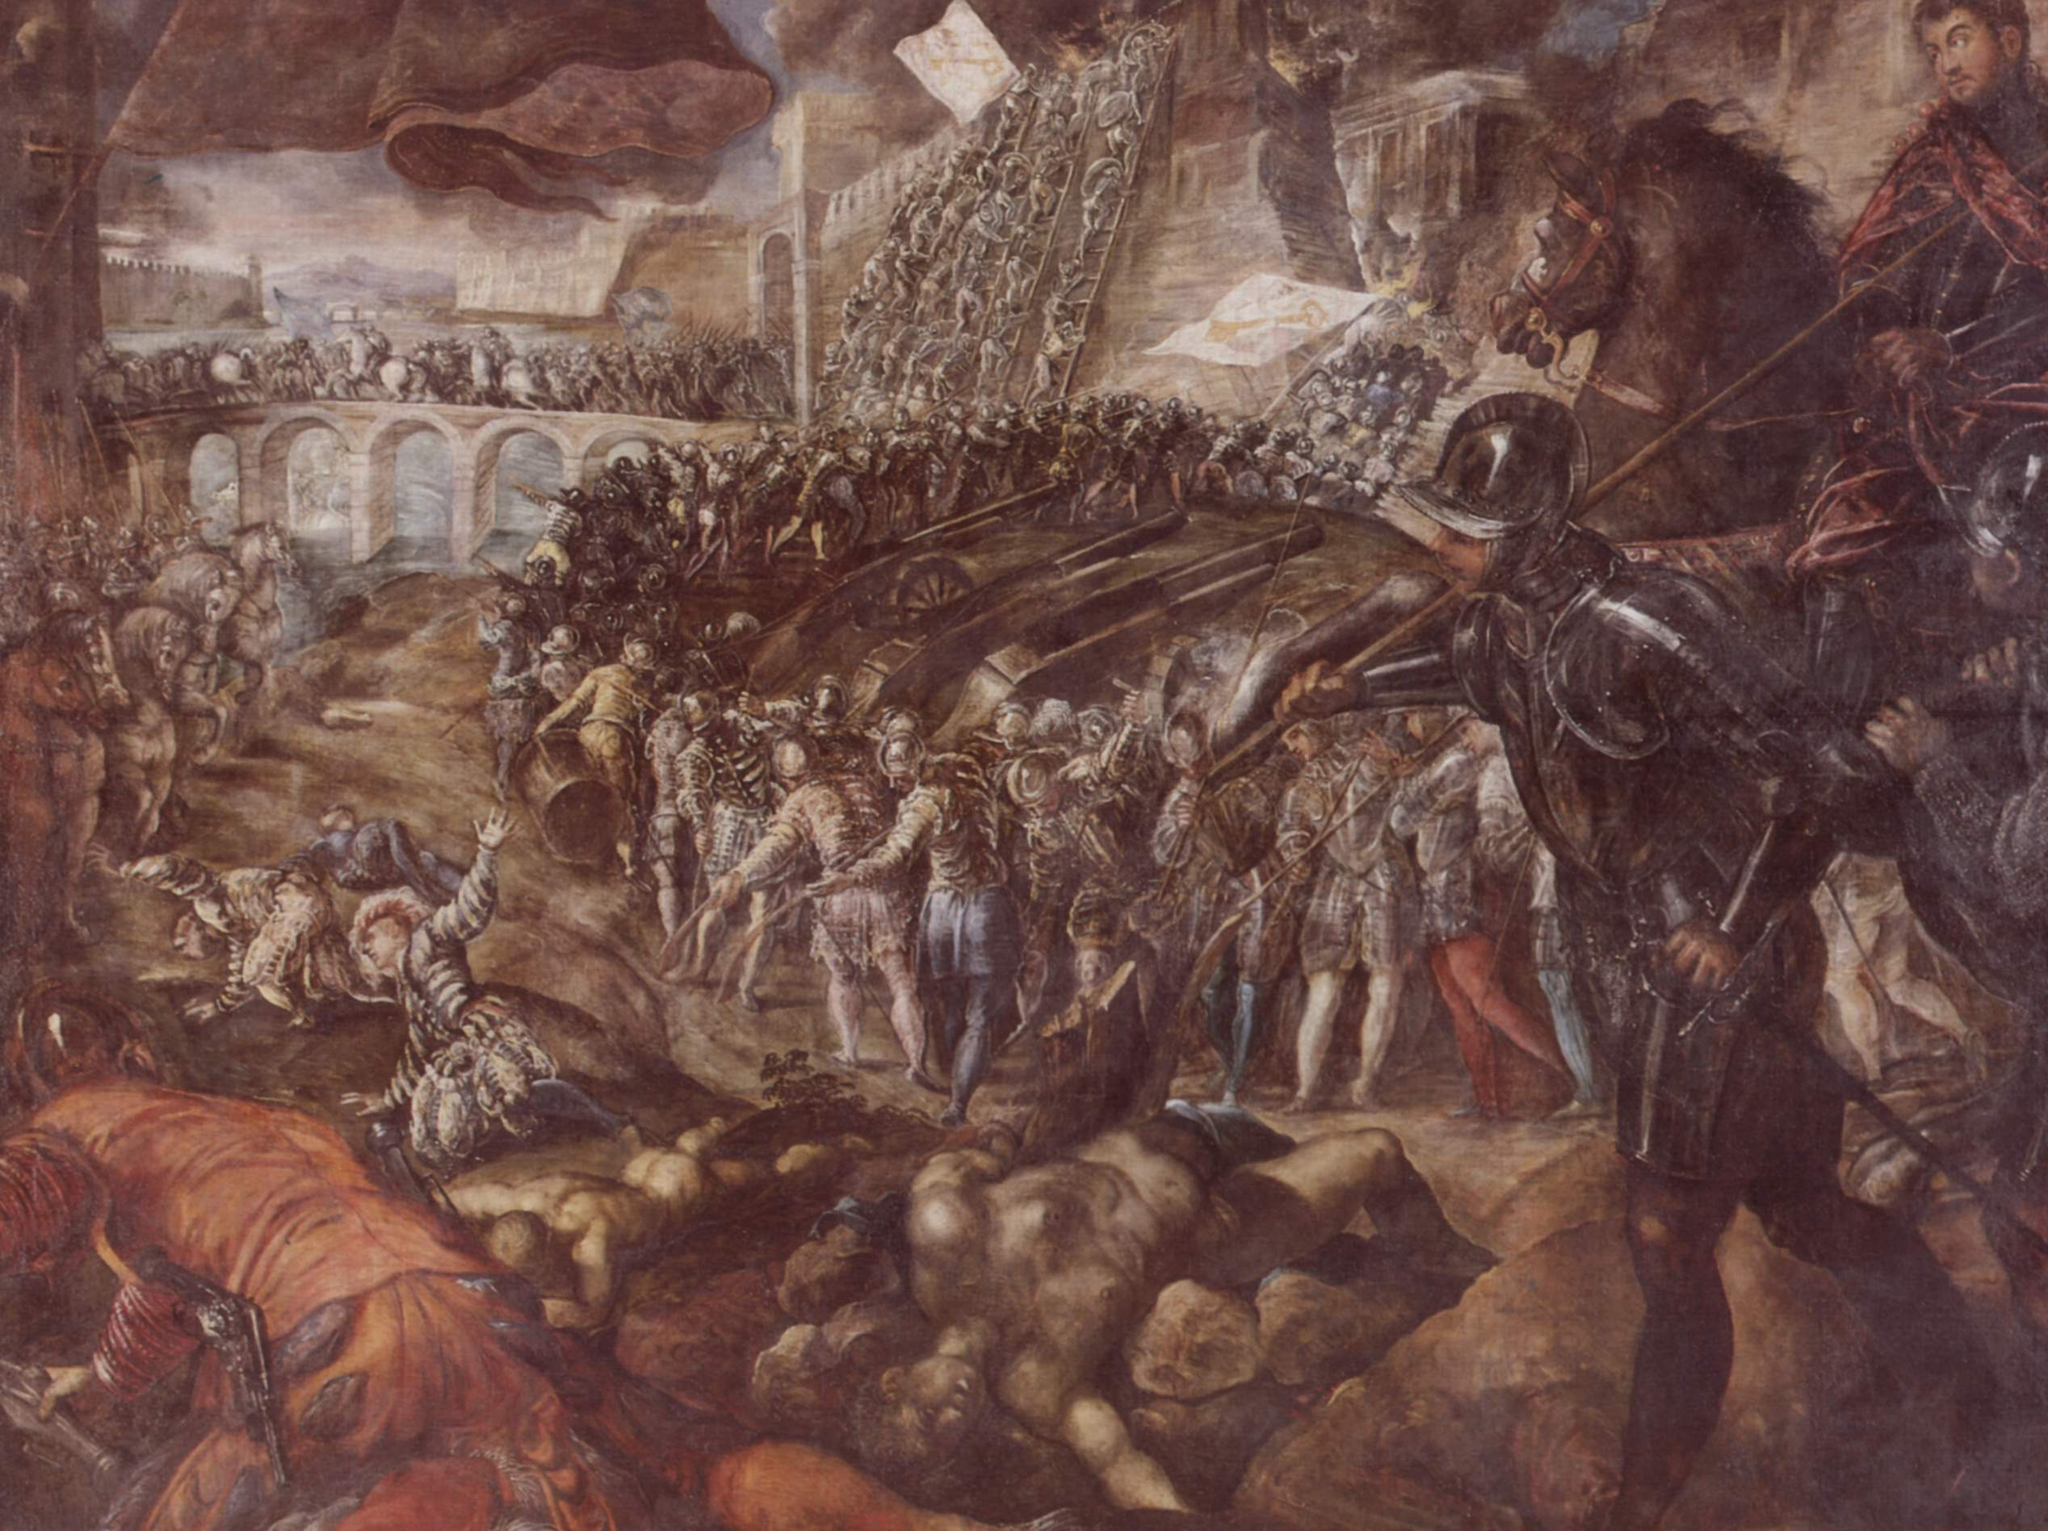Create a short poem that captures the essence of this battle scene. In a land where banners fly, beneath a brooding sky,
Clad in armor, hearts heavy, warriors fight and die.
Blades clash, shields splinter, cries of valor ring,
In the throes of fierce battle, fate's cruel sting.
Earthy tones of struggle, blue sky's stark divide,
Chaos reigns on the battlefield, no place to hide.
A story etched in time, of conflict and strife,
In the dance of death, the fragile breath of life. 